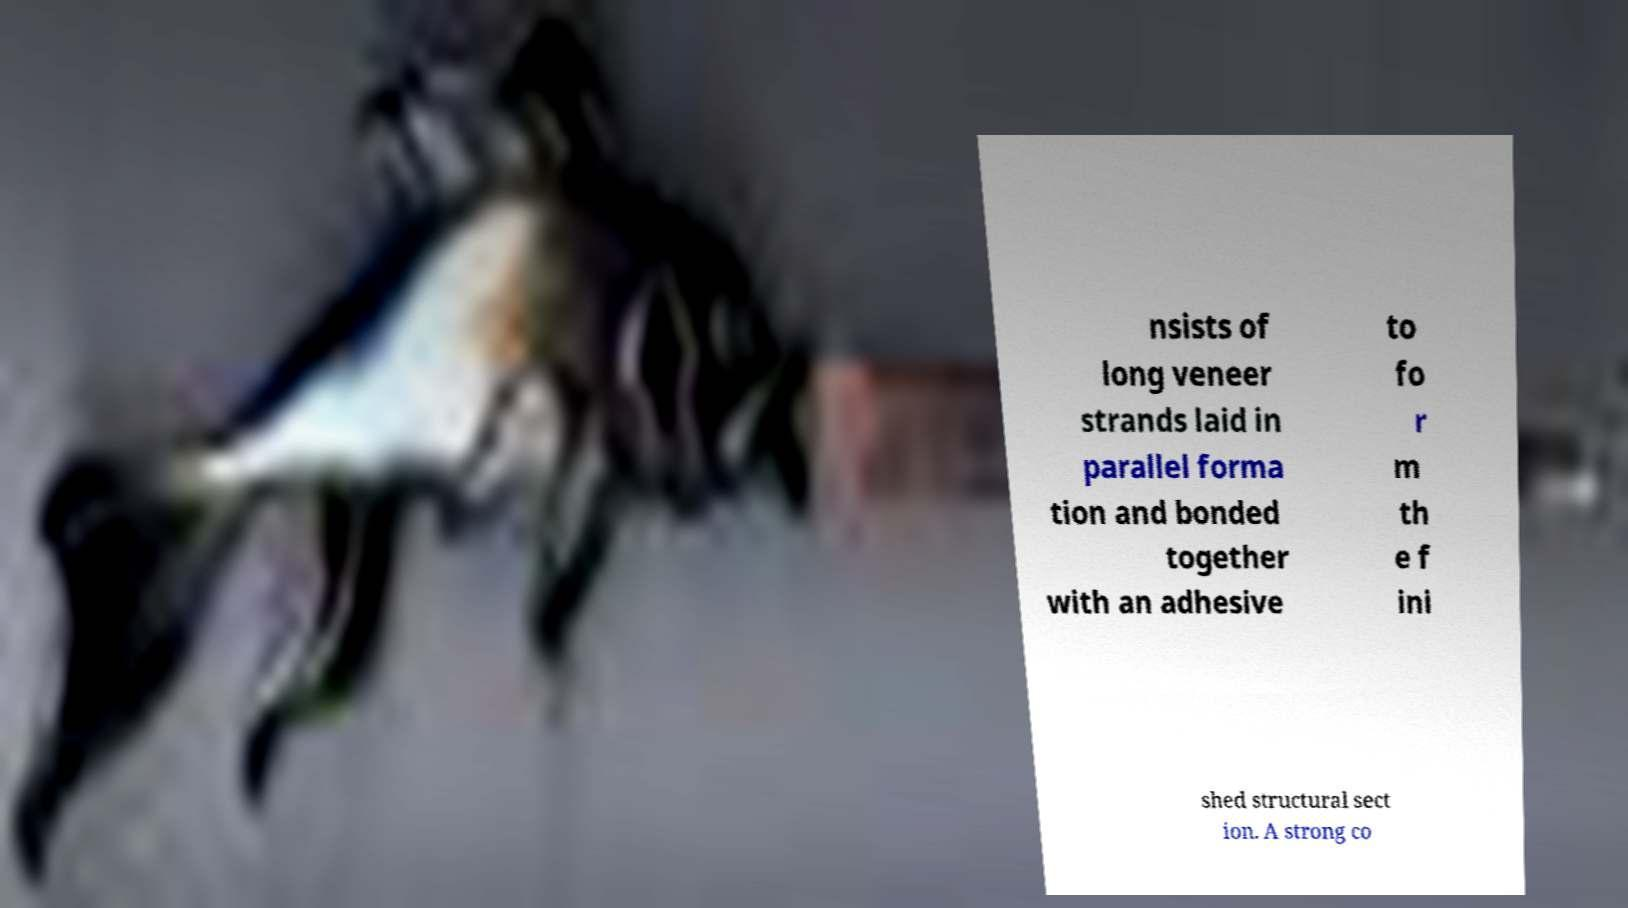Please identify and transcribe the text found in this image. nsists of long veneer strands laid in parallel forma tion and bonded together with an adhesive to fo r m th e f ini shed structural sect ion. A strong co 